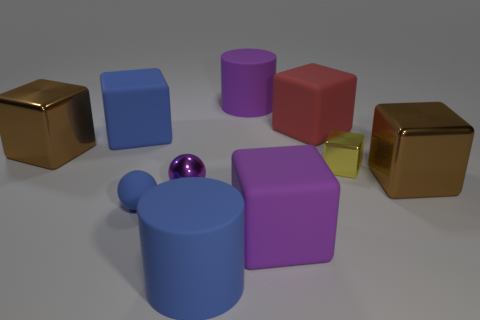Subtract all blue rubber blocks. How many blocks are left? 5 Subtract all purple cubes. How many cubes are left? 5 Subtract all cyan cubes. Subtract all blue spheres. How many cubes are left? 6 Subtract all cylinders. How many objects are left? 8 Subtract 0 red balls. How many objects are left? 10 Subtract all big red cubes. Subtract all big blue objects. How many objects are left? 7 Add 8 blue cubes. How many blue cubes are left? 9 Add 3 large purple cylinders. How many large purple cylinders exist? 4 